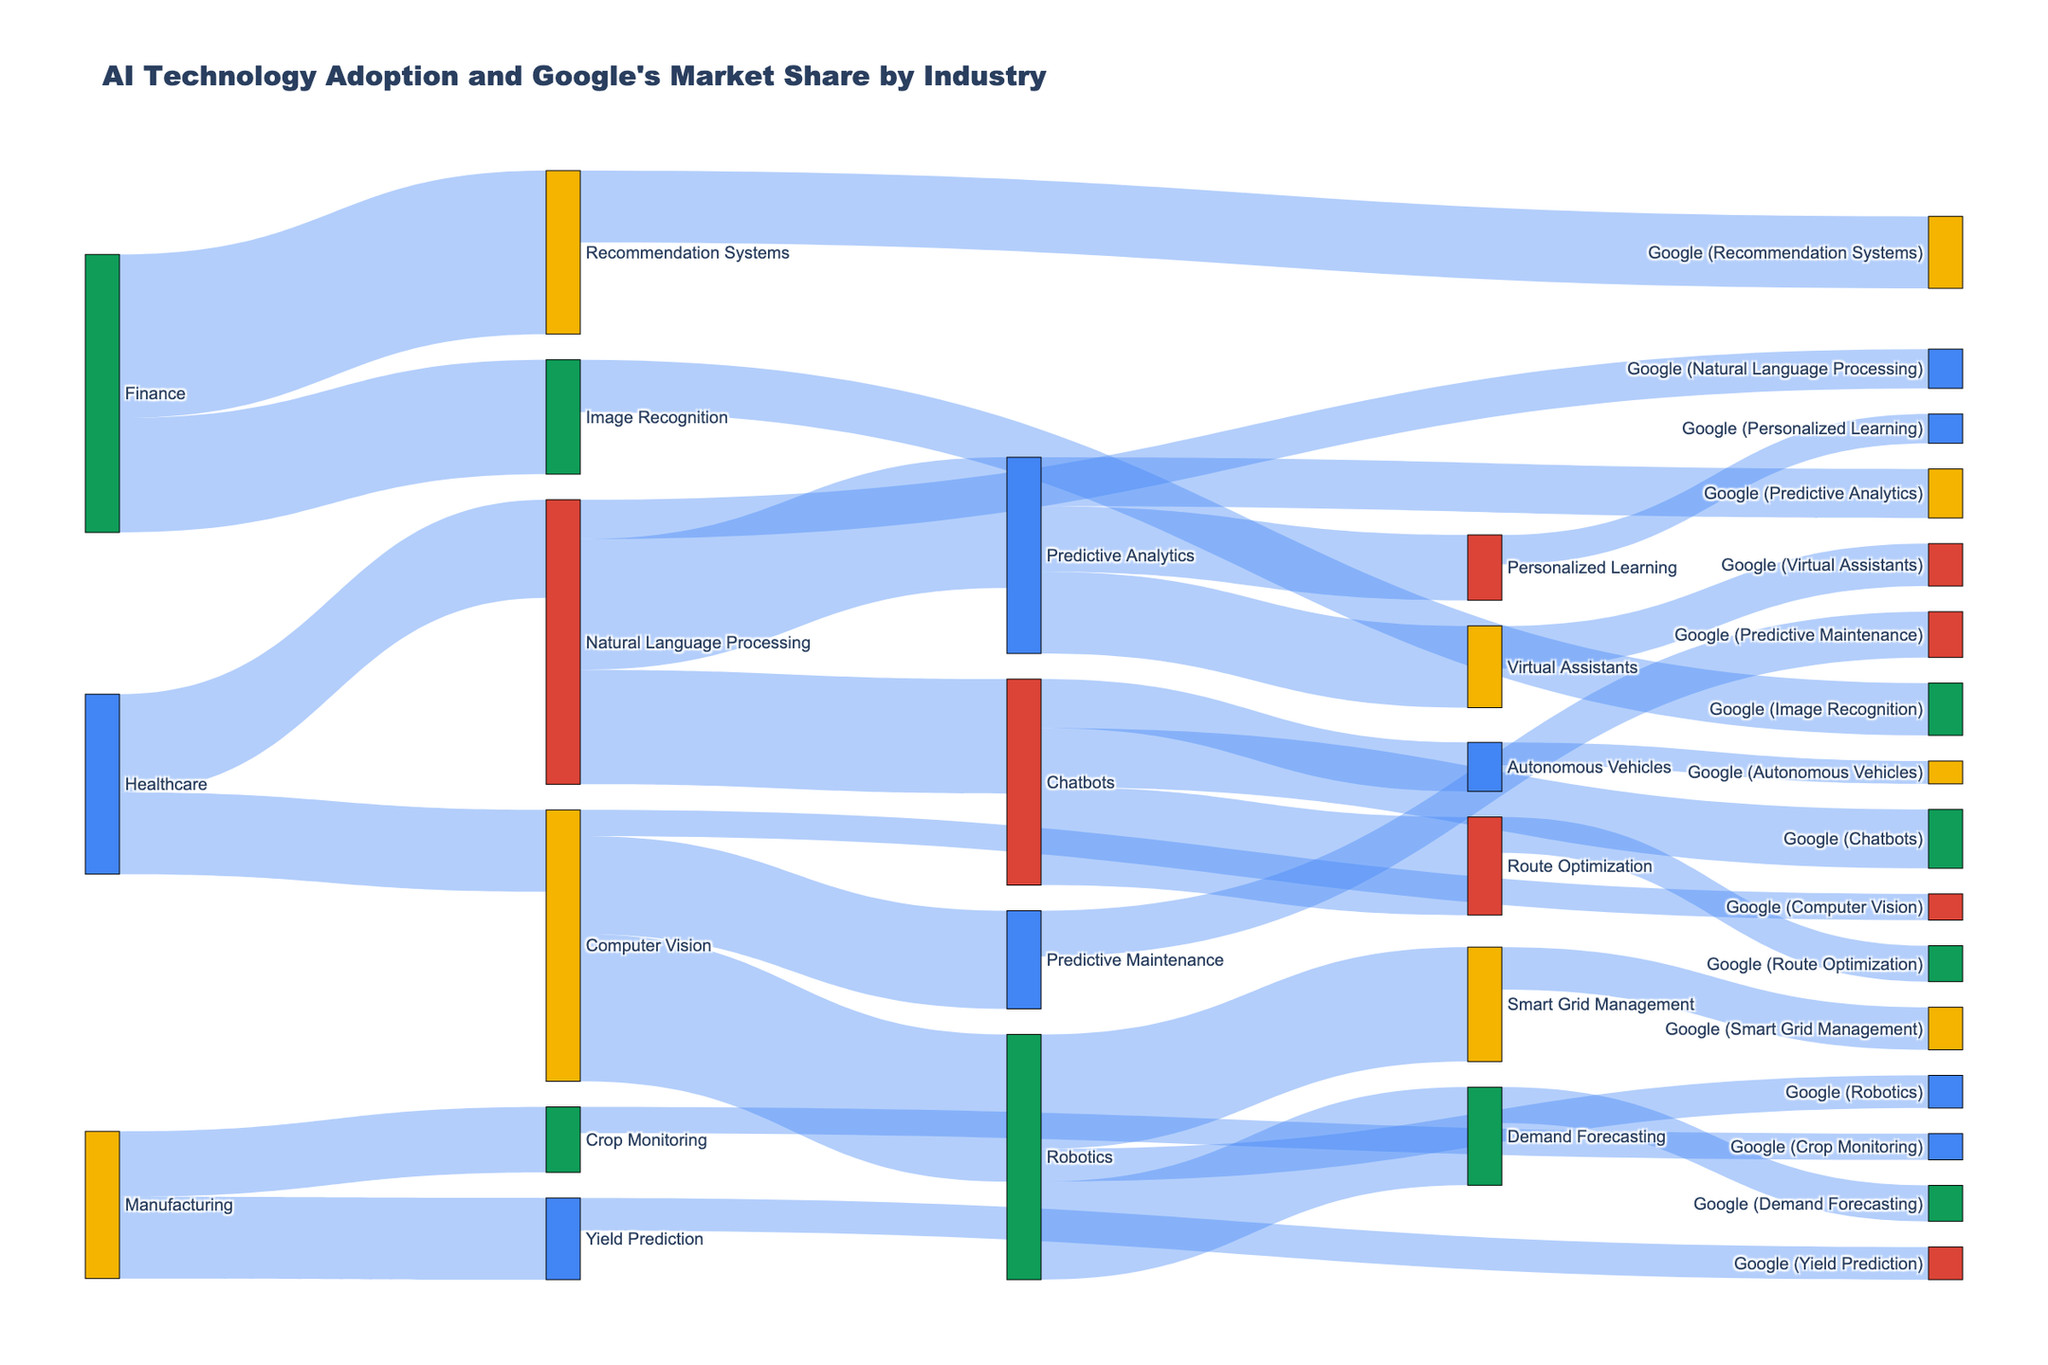what is the title of the figure? The title is typically displayed prominently at the top of the figure. For this Sankey diagram, the title provided in the code is "AI Technology Adoption and Google's Market Share by Industry."
Answer: "AI Technology Adoption and Google's Market Share by Industry" What industry has the highest AI technology adoption rate? To determine this, look for the industry with the largest value on the source side connecting to an AI technology. The data indicates that Retail has a 50 adoption rate for Recommendation Systems, which is the highest.
Answer: Retail Which AI technology has the highest adoption rate in Healthcare? Locate the section for Healthcare in the Sankey diagram and identify the AI technology with the largest value. For Healthcare, the highest adoption rate is Natural Language Processing with a value of 30.
Answer: Natural Language Processing Which industry has the least Google Market Share in the analyzed AI technologies? The lowest Google market share percentage for AI technologies is in Transportation for Autonomous Vehicles, with a market share of 7.
Answer: Transportation How much more is the adoption rate of Predictive Analytics compared to Chatbots in Finance? Identify and subtract the adoption rates of Predictive Analytics and Chatbots in Finance. Predictive Analytics has 40, and Chatbots have 35, thus 40 - 35 = 5.
Answer: 5 What is the total Google market share across all AI technologies in Retail? Add the Google market shares for all AI technologies within the Retail industry: 22 (Recommendation Systems) + 16 (Image Recognition) = 38.
Answer: 38 How does the adoption rate of Robotics in Manufacturing compare to the adoption rate of Computer Vision in Healthcare? Compare the adoption rates directly from the figure. Robotics in Manufacturing has a rate of 45, while Computer Vision in Healthcare has 25. Thus, 45 is greater than 25.
Answer: Robotics in Manufacturing has a higher adoption rate than Computer Vision in Healthcare What is the average Google market share for AI technologies in the Manufacturing industry? Sum the Google market shares for Manufacturing and divide by the number of technologies: (10+14)/2 = 24/2 = 12.
Answer: 12 Which AI technology has a higher Google market share in Agriculture: Crop Monitoring or Yield Prediction? Compare the Google market shares for Crop Monitoring and Yield Prediction in Agriculture. Crop Monitoring has 8, and Yield Prediction has 10, thus Yield Prediction is higher.
Answer: Yield Prediction Which industry has the most balanced adoption rates among two AI technologies? Evaluate the differences between the adoption rates in each industry. Energy has Smart Grid Management and Demand Forecasting with values of 35 and 30, respectively. The difference (35-30=5) is relatively small compared to other industries.
Answer: Energy 